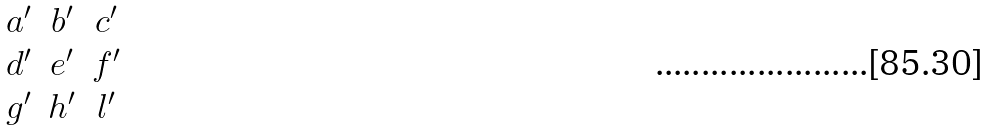Convert formula to latex. <formula><loc_0><loc_0><loc_500><loc_500>\begin{matrix} a ^ { \prime } & b ^ { \prime } & c ^ { \prime } \\ d ^ { \prime } & e ^ { \prime } & f ^ { \prime } \\ g ^ { \prime } & h ^ { \prime } & l ^ { \prime } \end{matrix}</formula> 